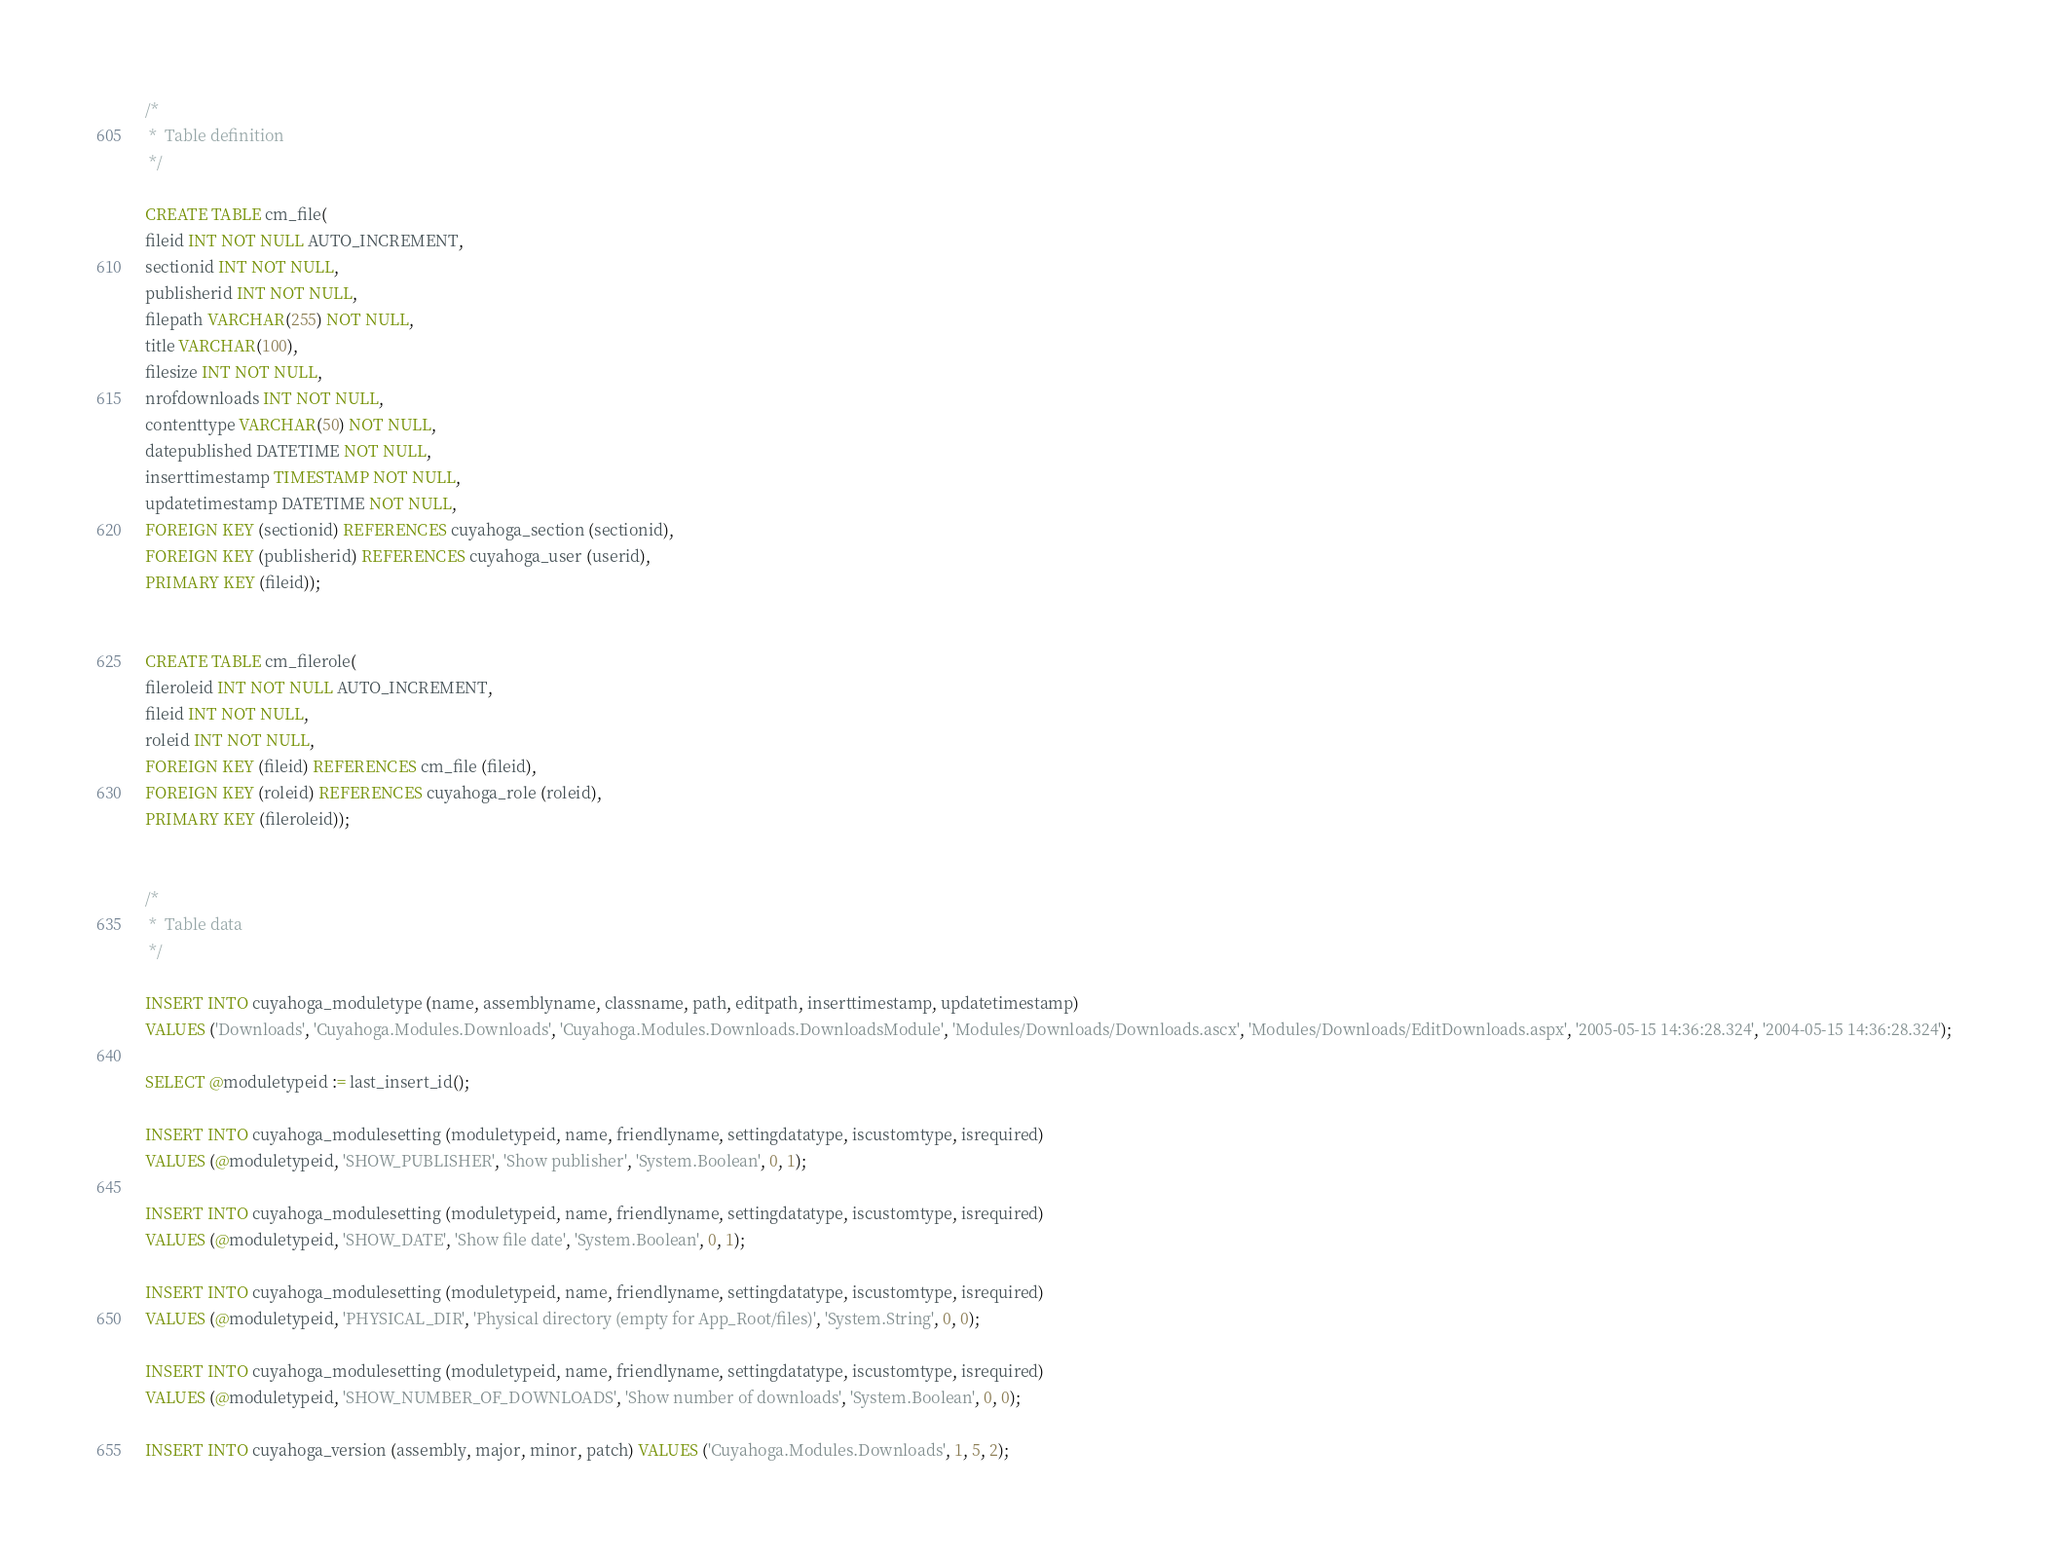<code> <loc_0><loc_0><loc_500><loc_500><_SQL_>/*
 *  Table definition
 */

CREATE TABLE cm_file(
fileid INT NOT NULL AUTO_INCREMENT,
sectionid INT NOT NULL,
publisherid INT NOT NULL,
filepath VARCHAR(255) NOT NULL,
title VARCHAR(100),
filesize INT NOT NULL,
nrofdownloads INT NOT NULL,
contenttype VARCHAR(50) NOT NULL,
datepublished DATETIME NOT NULL,
inserttimestamp TIMESTAMP NOT NULL,
updatetimestamp DATETIME NOT NULL,
FOREIGN KEY (sectionid) REFERENCES cuyahoga_section (sectionid),
FOREIGN KEY (publisherid) REFERENCES cuyahoga_user (userid),
PRIMARY KEY (fileid));


CREATE TABLE cm_filerole(
fileroleid INT NOT NULL AUTO_INCREMENT,
fileid INT NOT NULL,
roleid INT NOT NULL,
FOREIGN KEY (fileid) REFERENCES cm_file (fileid),
FOREIGN KEY (roleid) REFERENCES cuyahoga_role (roleid),
PRIMARY KEY (fileroleid));


/*
 *  Table data
 */

INSERT INTO cuyahoga_moduletype (name, assemblyname, classname, path, editpath, inserttimestamp, updatetimestamp)
VALUES ('Downloads', 'Cuyahoga.Modules.Downloads', 'Cuyahoga.Modules.Downloads.DownloadsModule', 'Modules/Downloads/Downloads.ascx', 'Modules/Downloads/EditDownloads.aspx', '2005-05-15 14:36:28.324', '2004-05-15 14:36:28.324');

SELECT @moduletypeid := last_insert_id();

INSERT INTO cuyahoga_modulesetting (moduletypeid, name, friendlyname, settingdatatype, iscustomtype, isrequired)
VALUES (@moduletypeid, 'SHOW_PUBLISHER', 'Show publisher', 'System.Boolean', 0, 1);

INSERT INTO cuyahoga_modulesetting (moduletypeid, name, friendlyname, settingdatatype, iscustomtype, isrequired)
VALUES (@moduletypeid, 'SHOW_DATE', 'Show file date', 'System.Boolean', 0, 1);

INSERT INTO cuyahoga_modulesetting (moduletypeid, name, friendlyname, settingdatatype, iscustomtype, isrequired)
VALUES (@moduletypeid, 'PHYSICAL_DIR', 'Physical directory (empty for App_Root/files)', 'System.String', 0, 0);

INSERT INTO cuyahoga_modulesetting (moduletypeid, name, friendlyname, settingdatatype, iscustomtype, isrequired) 
VALUES (@moduletypeid, 'SHOW_NUMBER_OF_DOWNLOADS', 'Show number of downloads', 'System.Boolean', 0, 0);

INSERT INTO cuyahoga_version (assembly, major, minor, patch) VALUES ('Cuyahoga.Modules.Downloads', 1, 5, 2);

</code> 